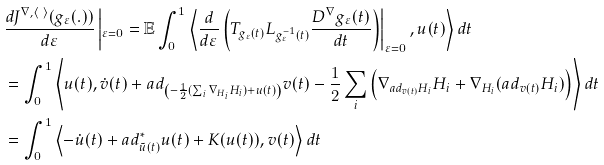Convert formula to latex. <formula><loc_0><loc_0><loc_500><loc_500>& \frac { d J ^ { \nabla , \langle \ \rangle } ( g _ { \varepsilon } ( . ) ) } { d \varepsilon } \left | _ { \varepsilon = 0 } = \mathbb { E } \int _ { 0 } ^ { 1 } \left \langle \frac { d } { d \varepsilon } \left ( T _ { g _ { \varepsilon } ( t ) } L _ { g _ { \varepsilon } ^ { - 1 } ( t ) } \frac { D ^ { \nabla } g _ { \varepsilon } ( t ) } { d t } \right ) \right | _ { \varepsilon = 0 } , u ( t ) \right \rangle d t \\ & = \int _ { 0 } ^ { 1 } \left \langle u ( t ) , \dot { v } ( t ) + a d _ { \left ( - \frac { 1 } { 2 } ( \sum _ { i } \nabla _ { H _ { i } } H _ { i } ) + u ( t ) \right ) } v ( t ) - \frac { 1 } { 2 } \sum _ { i } \left ( \nabla _ { a d _ { v ( t ) } H _ { i } } H _ { i } + \nabla _ { H _ { i } } ( a d _ { v ( t ) } H _ { i } ) \right ) \right \rangle d t \\ & = \int _ { 0 } ^ { 1 } \left \langle - \dot { u } ( t ) + a d ^ { * } _ { \tilde { u } ( t ) } u ( t ) + K ( u ( t ) ) , v ( t ) \right \rangle d t</formula> 